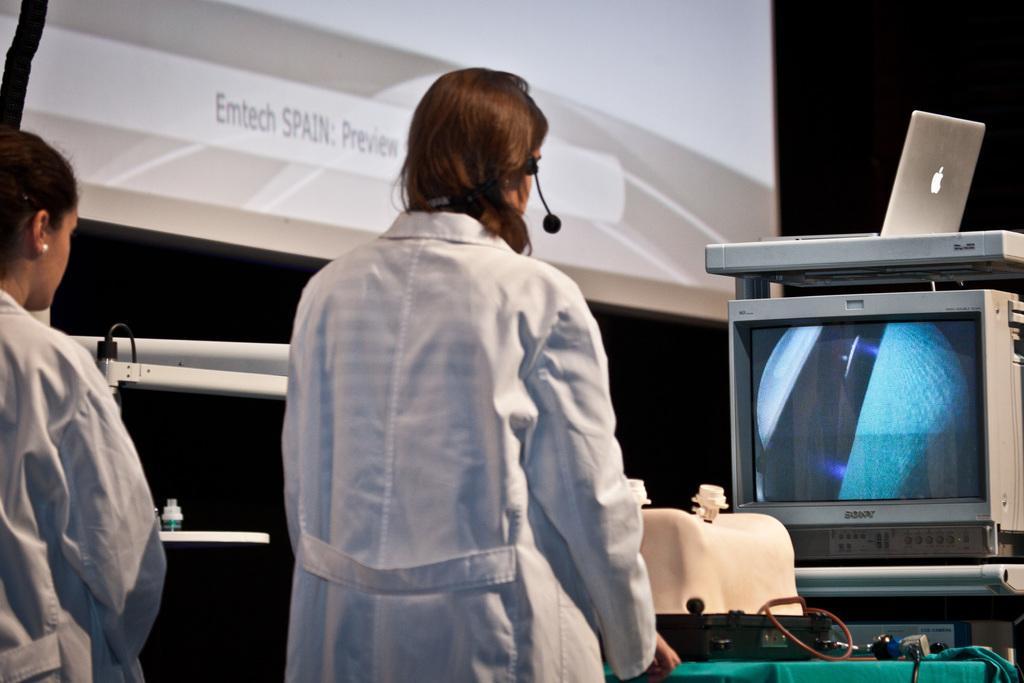Can you describe this image briefly? On the left corner of the image there is a person standing. And in the middle of the image there is a lady standing and she wore headsets. In front of her there is a table with equipment and wires. Behind the table there is a monitor with images. Above that there is a laptop. In the background there is a screen with something written on it. And also there are white color objects in the background. 